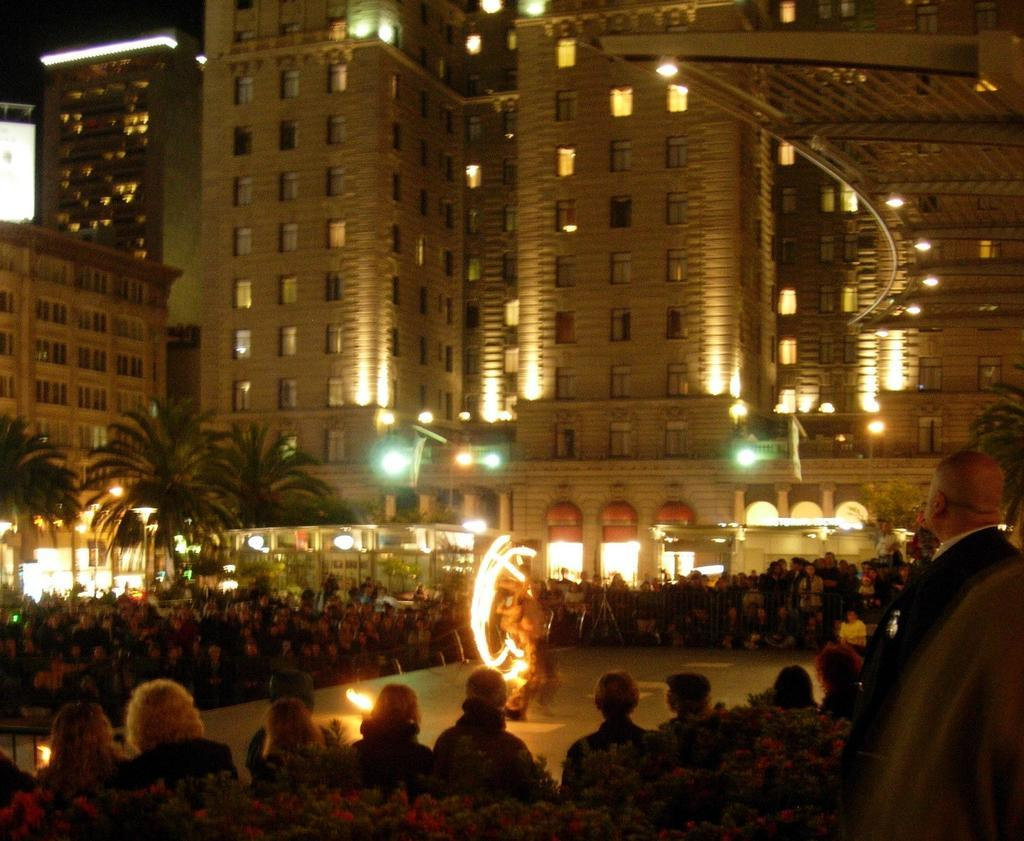How many people are in the image? There is a group of people in the image. What else can be seen in the image besides the people? There are plants, a person playing with fire, trees, lights, poles, flags, and buildings in the image. What type of vegetation is present in the image? There are plants and trees in the image. What can be used to identify the location or event in the image? The presence of flags, lights, and buildings might help identify the location or event in the image. How many snails can be seen crawling on the buildings in the image? There are no snails visible in the image; only people, plants, a person playing with fire, trees, lights, poles, flags, and buildings are present. 